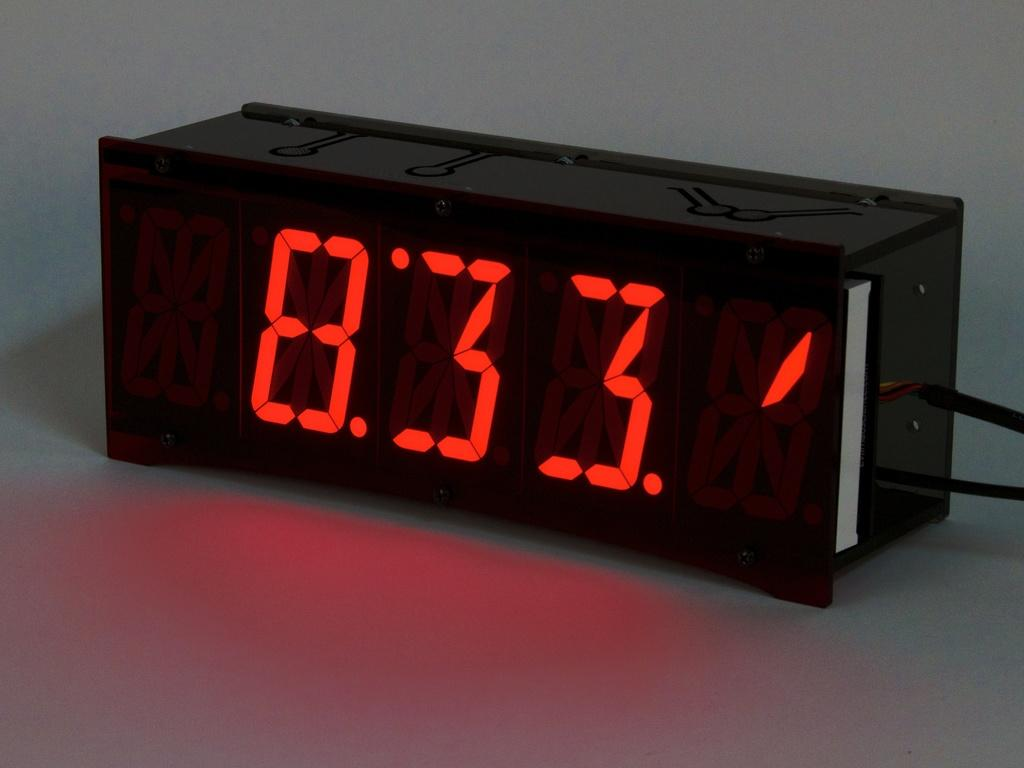<image>
Present a compact description of the photo's key features. A digital clock diplaying the time as 8:33 